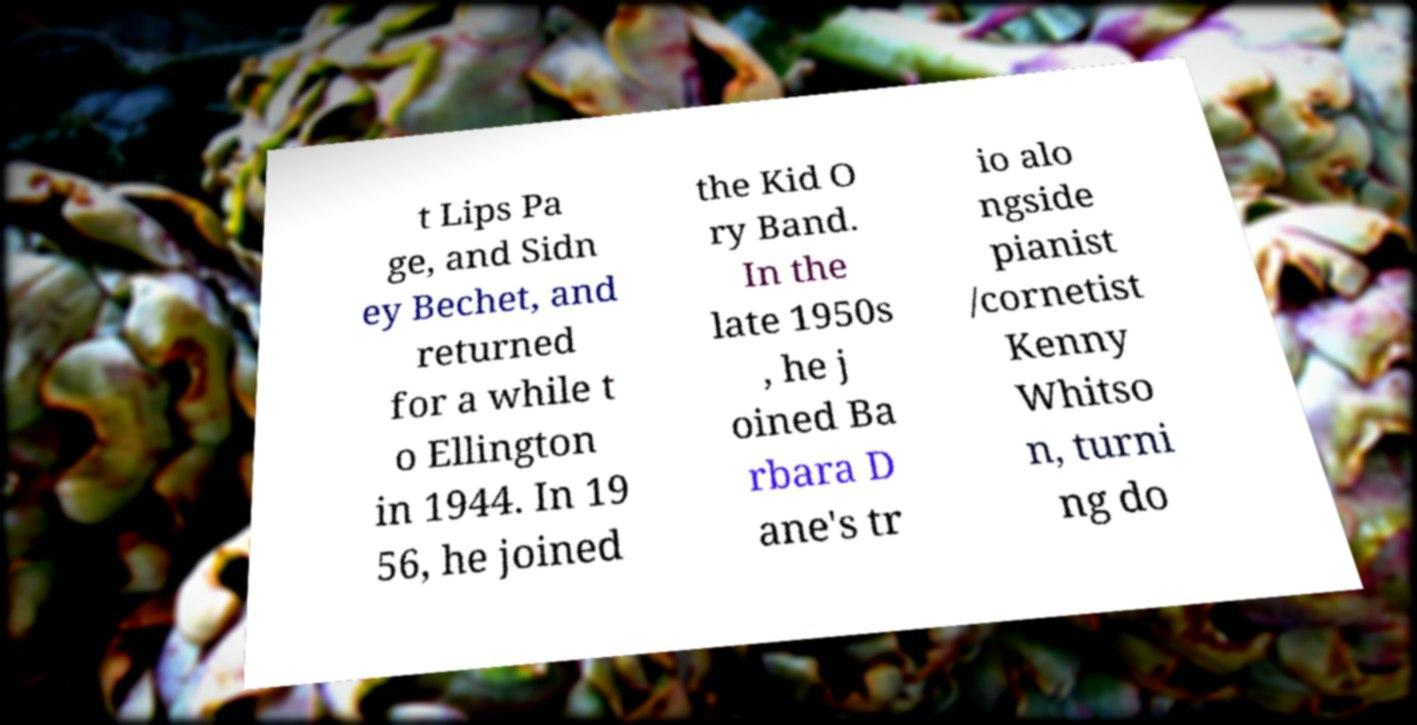Could you assist in decoding the text presented in this image and type it out clearly? t Lips Pa ge, and Sidn ey Bechet, and returned for a while t o Ellington in 1944. In 19 56, he joined the Kid O ry Band. In the late 1950s , he j oined Ba rbara D ane's tr io alo ngside pianist /cornetist Kenny Whitso n, turni ng do 